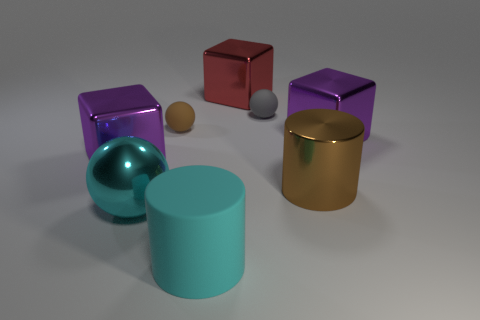Subtract all purple shiny cubes. How many cubes are left? 1 Add 2 big cyan metal objects. How many objects exist? 10 Subtract all cyan spheres. How many spheres are left? 2 Subtract all blocks. How many objects are left? 5 Subtract all yellow cylinders. How many purple cubes are left? 2 Subtract 0 brown cubes. How many objects are left? 8 Subtract 1 blocks. How many blocks are left? 2 Subtract all yellow cubes. Subtract all brown spheres. How many cubes are left? 3 Subtract all red cubes. Subtract all big red rubber things. How many objects are left? 7 Add 7 cyan metal things. How many cyan metal things are left? 8 